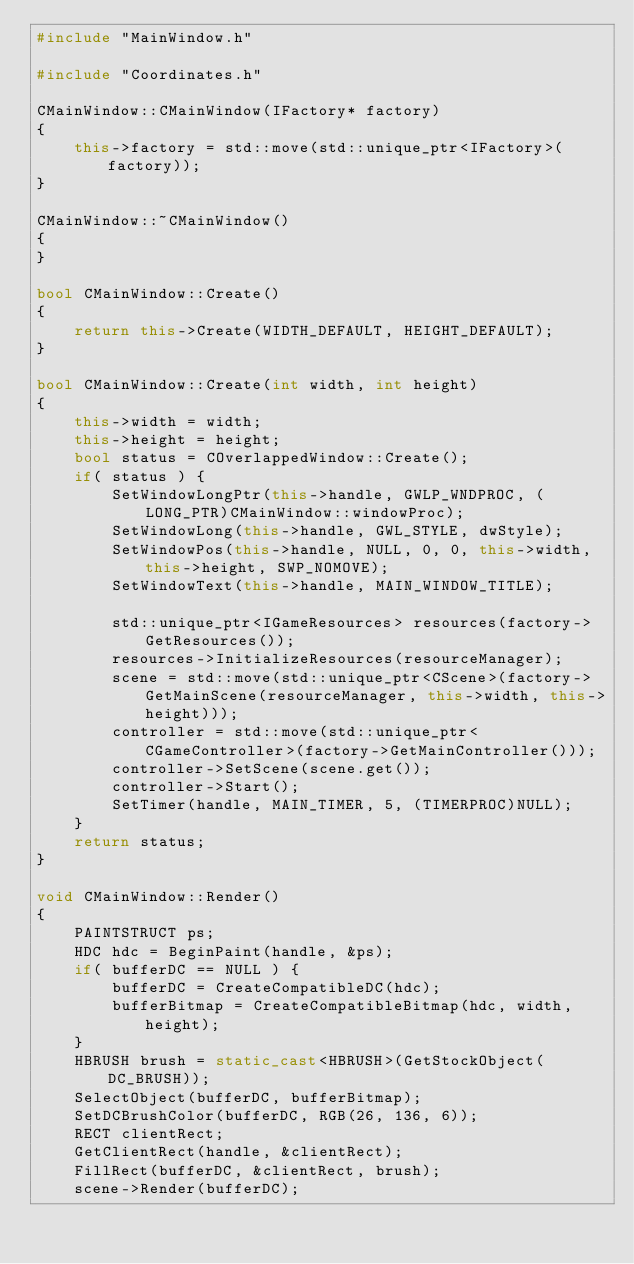<code> <loc_0><loc_0><loc_500><loc_500><_C++_>#include "MainWindow.h"

#include "Coordinates.h"

CMainWindow::CMainWindow(IFactory* factory)
{
	this->factory = std::move(std::unique_ptr<IFactory>(factory));
}

CMainWindow::~CMainWindow()
{
}

bool CMainWindow::Create()
{
	return this->Create(WIDTH_DEFAULT, HEIGHT_DEFAULT);	
}

bool CMainWindow::Create(int width, int height)
{
	this->width = width;
	this->height = height;
	bool status = COverlappedWindow::Create();
	if( status ) {
		SetWindowLongPtr(this->handle, GWLP_WNDPROC, (LONG_PTR)CMainWindow::windowProc);
		SetWindowLong(this->handle, GWL_STYLE, dwStyle);
		SetWindowPos(this->handle, NULL, 0, 0, this->width, this->height, SWP_NOMOVE);
		SetWindowText(this->handle, MAIN_WINDOW_TITLE);

		std::unique_ptr<IGameResources> resources(factory->GetResources());
		resources->InitializeResources(resourceManager);
		scene = std::move(std::unique_ptr<CScene>(factory->GetMainScene(resourceManager, this->width, this->height)));
		controller = std::move(std::unique_ptr<CGameController>(factory->GetMainController()));
		controller->SetScene(scene.get());
		controller->Start();
		SetTimer(handle, MAIN_TIMER, 5, (TIMERPROC)NULL);
	}
	return status;
}

void CMainWindow::Render()
{
	PAINTSTRUCT ps;
	HDC hdc = BeginPaint(handle, &ps);
	if( bufferDC == NULL ) {
		bufferDC = CreateCompatibleDC(hdc);
		bufferBitmap = CreateCompatibleBitmap(hdc, width, height);
	}
	HBRUSH brush = static_cast<HBRUSH>(GetStockObject(DC_BRUSH));
	SelectObject(bufferDC, bufferBitmap);
	SetDCBrushColor(bufferDC, RGB(26, 136, 6));
	RECT clientRect;
	GetClientRect(handle, &clientRect);
	FillRect(bufferDC, &clientRect, brush);
	scene->Render(bufferDC);</code> 